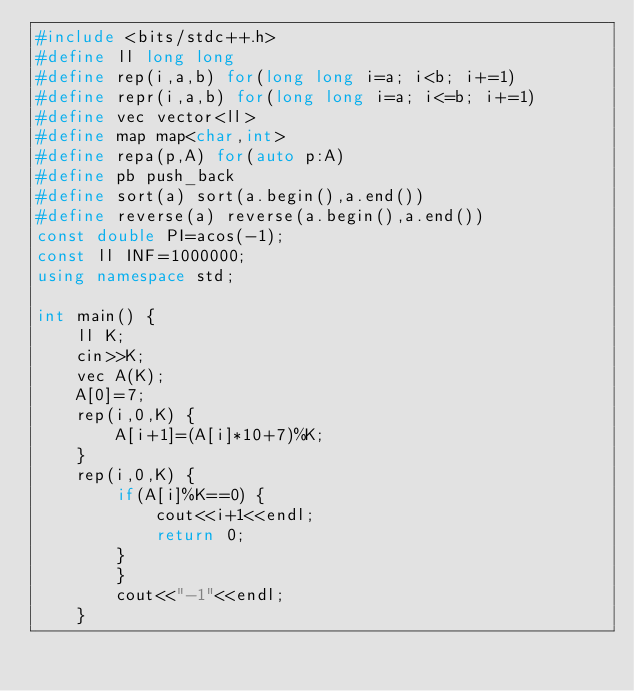<code> <loc_0><loc_0><loc_500><loc_500><_C++_>#include <bits/stdc++.h>
#define ll long long
#define rep(i,a,b) for(long long i=a; i<b; i+=1)
#define repr(i,a,b) for(long long i=a; i<=b; i+=1)
#define vec vector<ll>
#define map map<char,int>
#define repa(p,A) for(auto p:A)
#define pb push_back
#define sort(a) sort(a.begin(),a.end())
#define reverse(a) reverse(a.begin(),a.end())
const double PI=acos(-1);
const ll INF=1000000;
using namespace std;

int main() {
    ll K;
    cin>>K;
    vec A(K);
    A[0]=7;
    rep(i,0,K) {
        A[i+1]=(A[i]*10+7)%K;
    }
    rep(i,0,K) {
        if(A[i]%K==0) {
            cout<<i+1<<endl;
            return 0;
        }
        }
        cout<<"-1"<<endl;
    }
</code> 